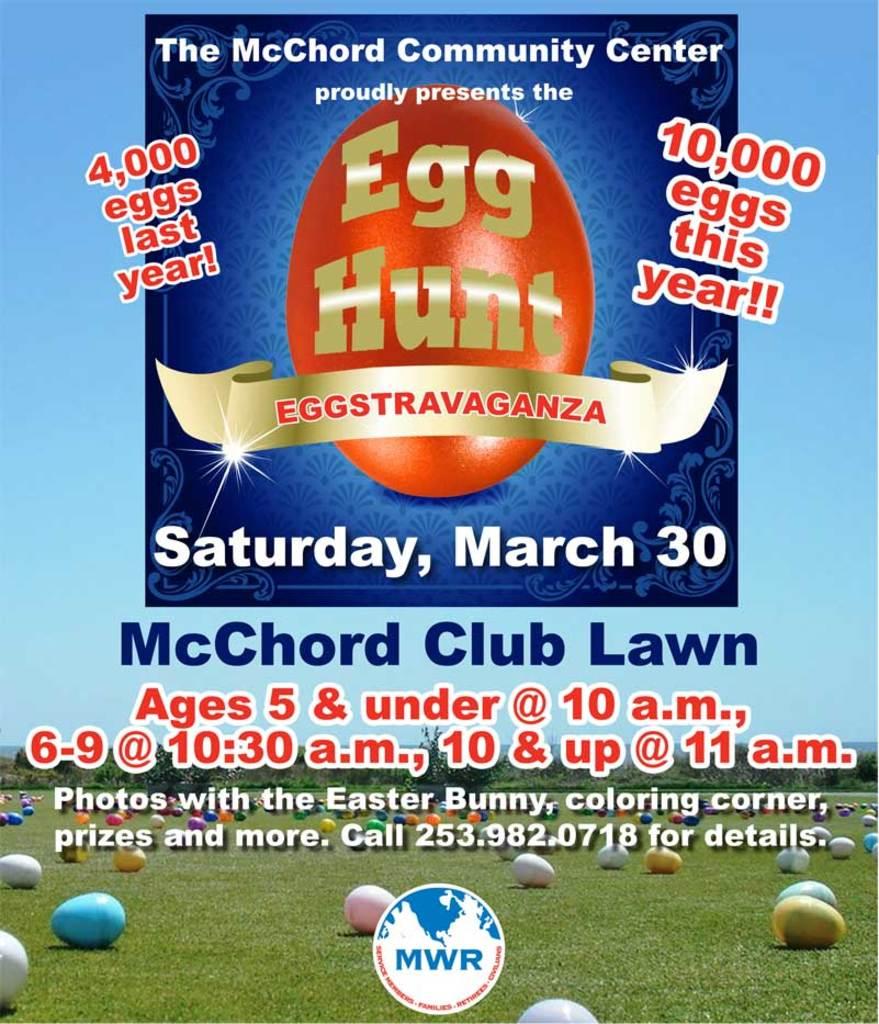What event is this?
Your response must be concise. Egg hunt. What day is this event?
Provide a short and direct response. Saturday. 